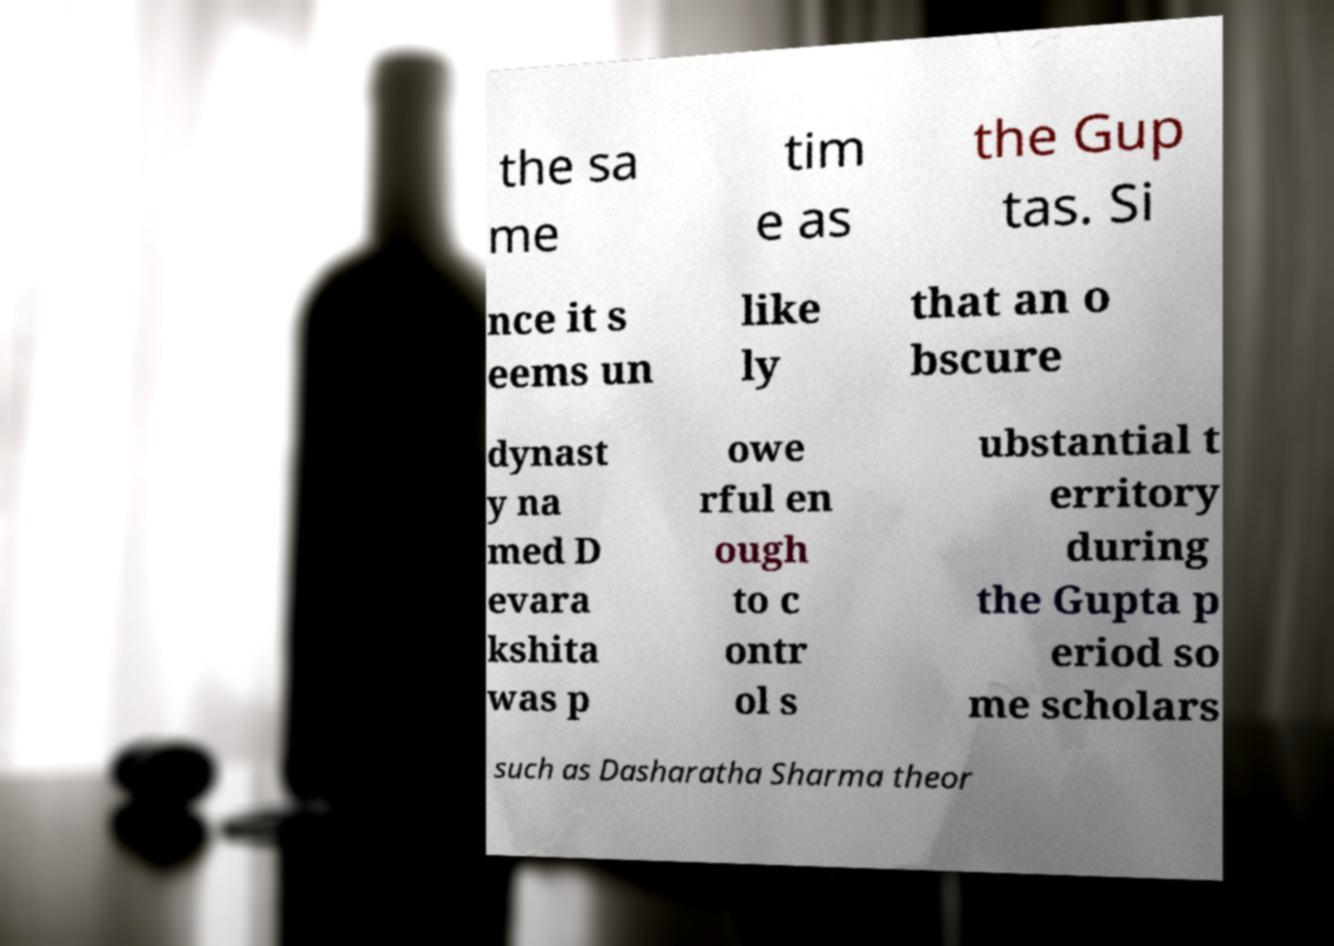Please identify and transcribe the text found in this image. the sa me tim e as the Gup tas. Si nce it s eems un like ly that an o bscure dynast y na med D evara kshita was p owe rful en ough to c ontr ol s ubstantial t erritory during the Gupta p eriod so me scholars such as Dasharatha Sharma theor 